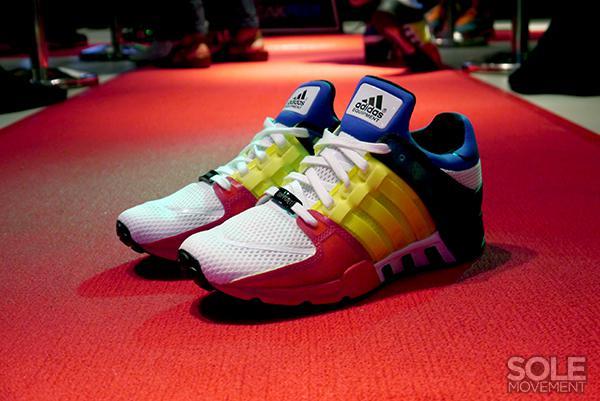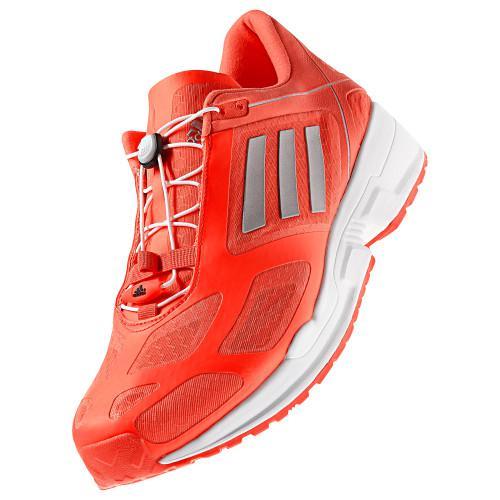The first image is the image on the left, the second image is the image on the right. Considering the images on both sides, is "One of the images is a single shoe facing left." valid? Answer yes or no. Yes. The first image is the image on the left, the second image is the image on the right. Analyze the images presented: Is the assertion "One image contains a single sneaker, and the other shows a pair of sneakers displayed with a sole-first shoe on its side and a rightside-up shoe leaning in front of it." valid? Answer yes or no. No. 